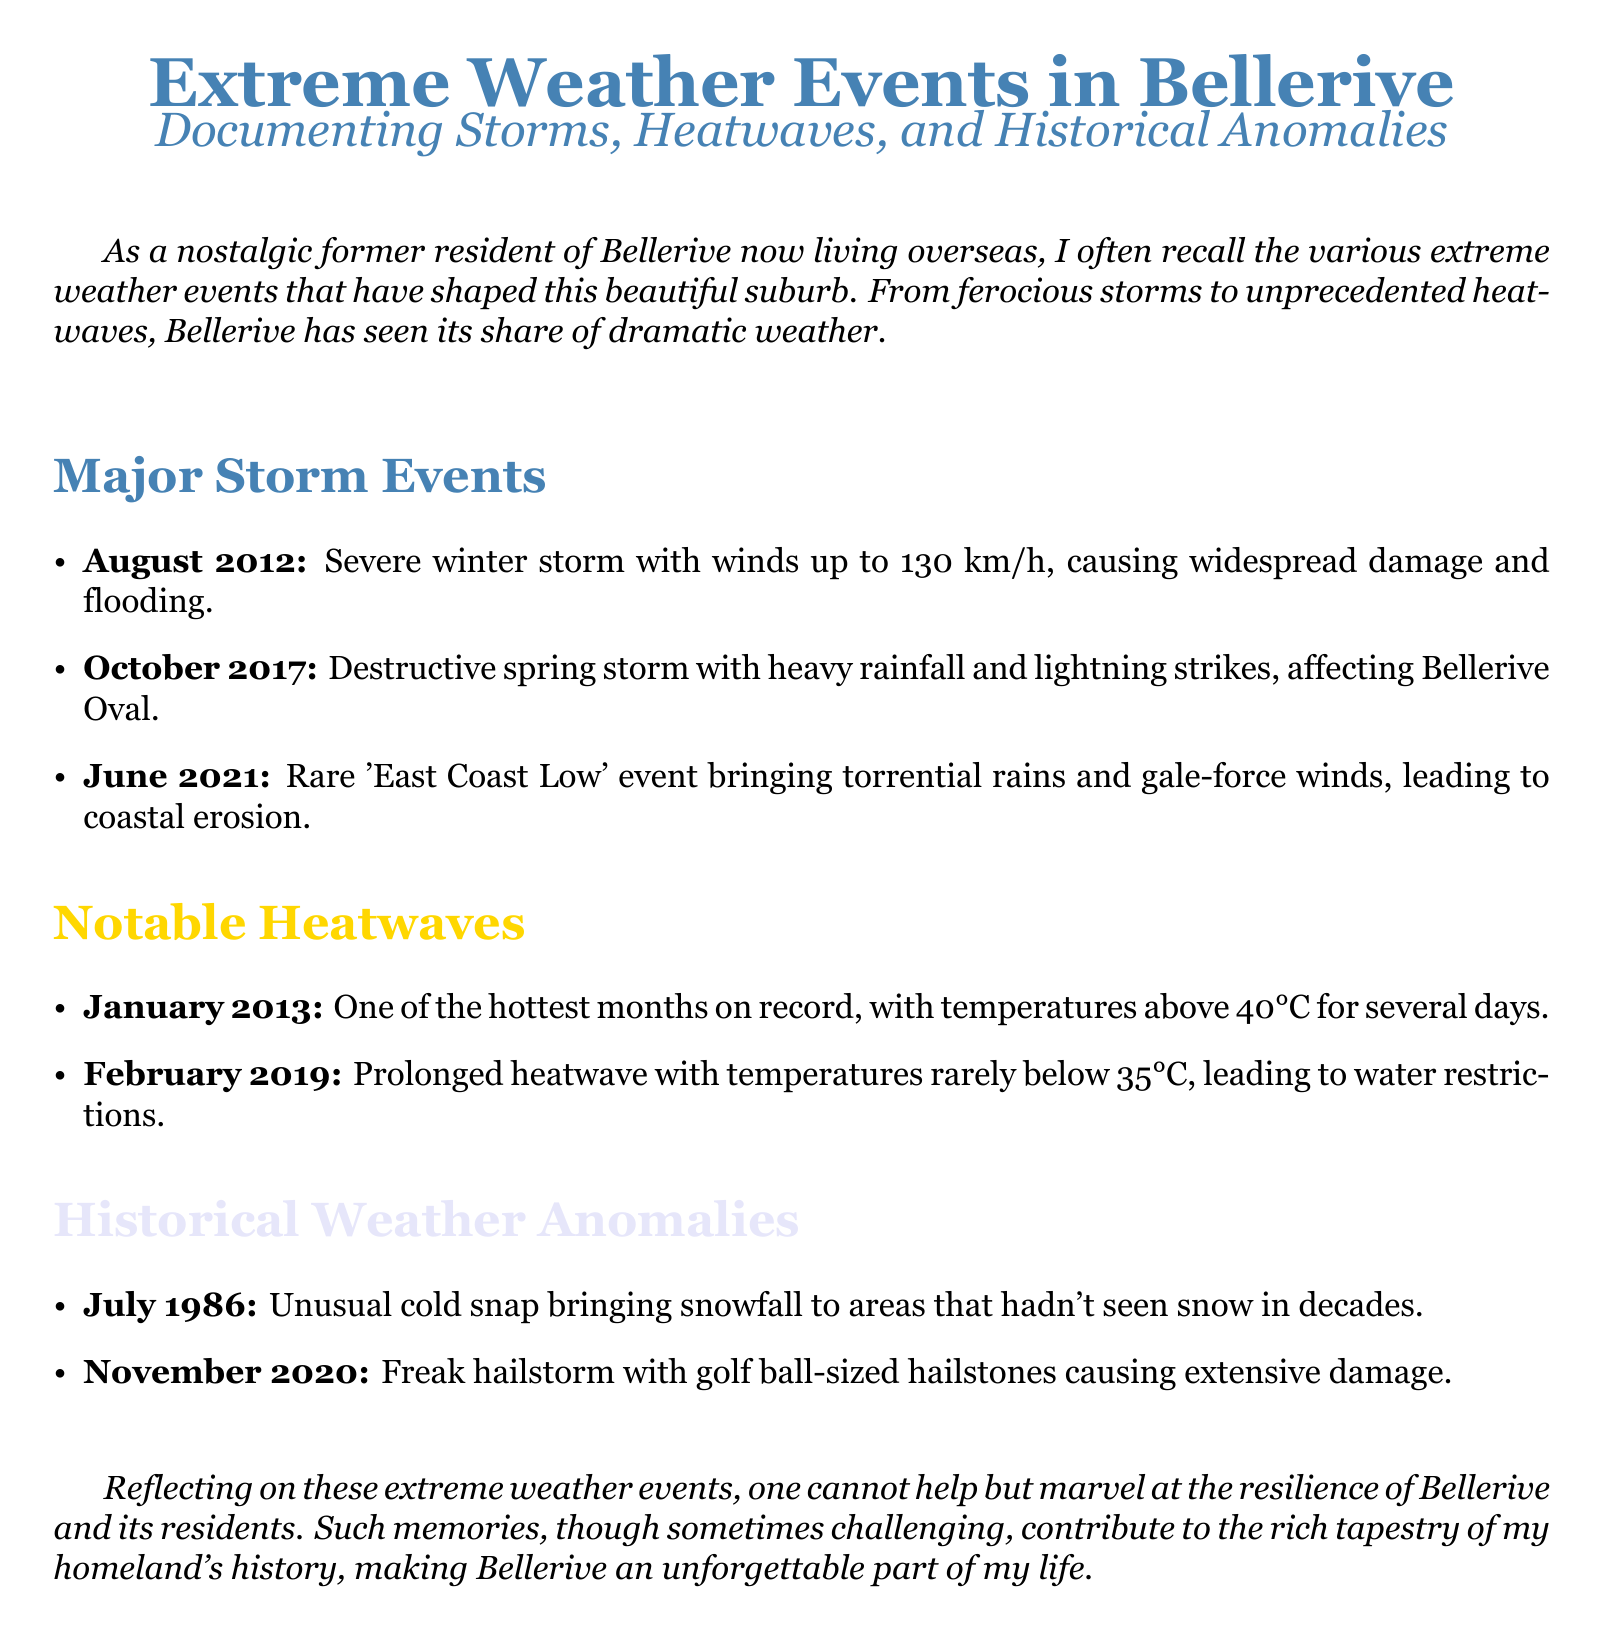What was the wind speed during the August 2012 storm? The document states that the August 2012 storm had winds up to 130 km/h.
Answer: 130 km/h What significant weather event occurred in June 2021? The document mentions a rare 'East Coast Low' event that occurred in June 2021.
Answer: 'East Coast Low' What was unusual about the weather in July 1986? The document describes a cold snap in July 1986 that brought snowfall to areas that hadn't seen snow in decades.
Answer: Snowfall How many heatwaves are noted in the document? The document lists two notable heatwaves occurring in January 2013 and February 2019.
Answer: Two What type of damage occurred during the November 2020 event? The document notes extensive damage caused by a freak hailstorm with golf ball-sized hailstones in November 2020.
Answer: Extensive damage In what month did Bellerive experience one of the hottest months on record? The document states that January 2013 was one of the hottest months on record.
Answer: January 2013 What kind of storm affected Bellerive Oval in October 2017? The document describes a destructive spring storm affecting Bellerive Oval in October 2017.
Answer: Destructive spring storm What is the color associated with the section on major storm events? The document uses the color defined as 'stormy' for the major storm events section.
Answer: Stormy What weather condition led to water restrictions in February 2019? The document indicates that a prolonged heatwave in February 2019 led to water restrictions.
Answer: Prolonged heatwave 